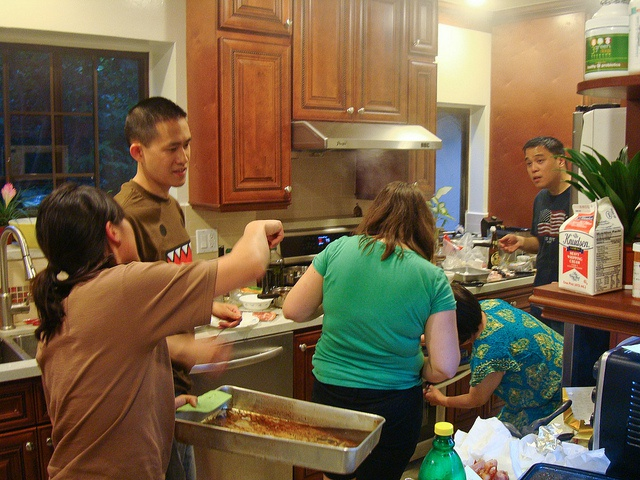Describe the objects in this image and their specific colors. I can see people in lightyellow, maroon, brown, and black tones, people in lightyellow, black, green, teal, and maroon tones, people in lightyellow, black, teal, darkblue, and olive tones, people in lightyellow, brown, maroon, and black tones, and people in lightyellow, black, brown, and maroon tones in this image. 